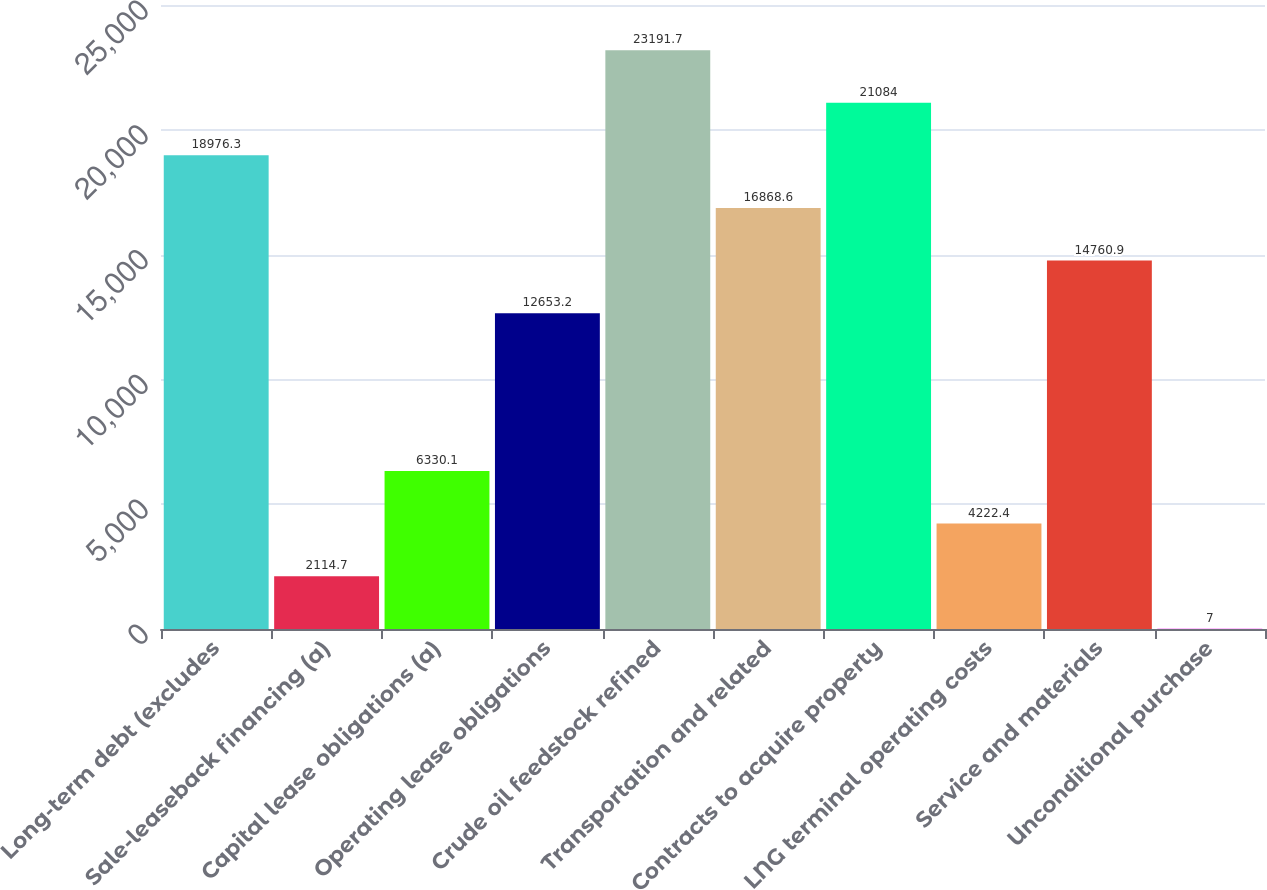<chart> <loc_0><loc_0><loc_500><loc_500><bar_chart><fcel>Long-term debt (excludes<fcel>Sale-leaseback financing (a)<fcel>Capital lease obligations (a)<fcel>Operating lease obligations<fcel>Crude oil feedstock refined<fcel>Transportation and related<fcel>Contracts to acquire property<fcel>LNG terminal operating costs<fcel>Service and materials<fcel>Unconditional purchase<nl><fcel>18976.3<fcel>2114.7<fcel>6330.1<fcel>12653.2<fcel>23191.7<fcel>16868.6<fcel>21084<fcel>4222.4<fcel>14760.9<fcel>7<nl></chart> 